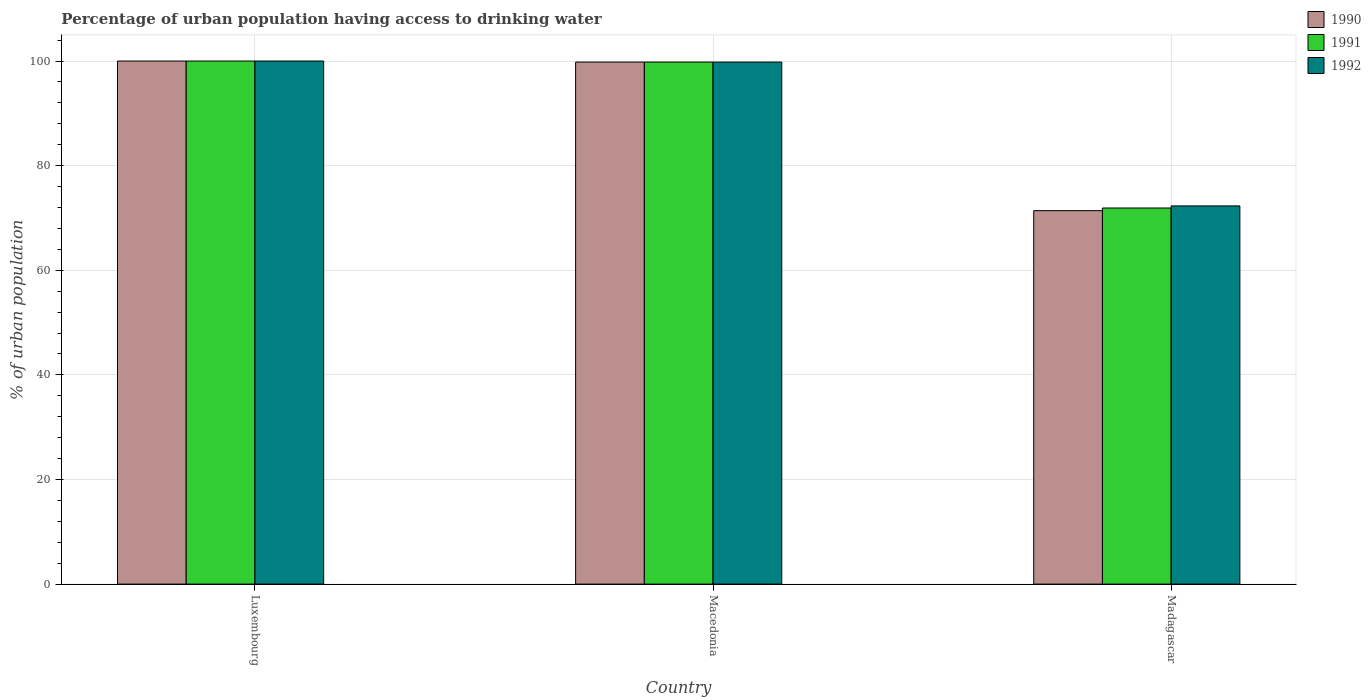How many different coloured bars are there?
Provide a short and direct response. 3. How many groups of bars are there?
Make the answer very short. 3. Are the number of bars per tick equal to the number of legend labels?
Offer a terse response. Yes. How many bars are there on the 1st tick from the left?
Ensure brevity in your answer.  3. What is the label of the 3rd group of bars from the left?
Offer a very short reply. Madagascar. In how many cases, is the number of bars for a given country not equal to the number of legend labels?
Your answer should be compact. 0. What is the percentage of urban population having access to drinking water in 1990 in Macedonia?
Provide a short and direct response. 99.8. Across all countries, what is the minimum percentage of urban population having access to drinking water in 1992?
Your answer should be compact. 72.3. In which country was the percentage of urban population having access to drinking water in 1990 maximum?
Provide a short and direct response. Luxembourg. In which country was the percentage of urban population having access to drinking water in 1991 minimum?
Offer a very short reply. Madagascar. What is the total percentage of urban population having access to drinking water in 1991 in the graph?
Your answer should be compact. 271.7. What is the difference between the percentage of urban population having access to drinking water in 1991 in Luxembourg and that in Macedonia?
Offer a very short reply. 0.2. What is the difference between the percentage of urban population having access to drinking water in 1991 in Madagascar and the percentage of urban population having access to drinking water in 1990 in Macedonia?
Offer a terse response. -27.9. What is the average percentage of urban population having access to drinking water in 1990 per country?
Ensure brevity in your answer.  90.4. What is the ratio of the percentage of urban population having access to drinking water in 1992 in Macedonia to that in Madagascar?
Ensure brevity in your answer.  1.38. Is the percentage of urban population having access to drinking water in 1991 in Luxembourg less than that in Macedonia?
Your answer should be very brief. No. Is the difference between the percentage of urban population having access to drinking water in 1992 in Luxembourg and Madagascar greater than the difference between the percentage of urban population having access to drinking water in 1991 in Luxembourg and Madagascar?
Make the answer very short. No. What is the difference between the highest and the second highest percentage of urban population having access to drinking water in 1992?
Provide a short and direct response. -27.5. What is the difference between the highest and the lowest percentage of urban population having access to drinking water in 1992?
Make the answer very short. 27.7. In how many countries, is the percentage of urban population having access to drinking water in 1992 greater than the average percentage of urban population having access to drinking water in 1992 taken over all countries?
Provide a succinct answer. 2. How many bars are there?
Keep it short and to the point. 9. How many countries are there in the graph?
Offer a terse response. 3. Does the graph contain grids?
Keep it short and to the point. Yes. Where does the legend appear in the graph?
Give a very brief answer. Top right. How many legend labels are there?
Keep it short and to the point. 3. What is the title of the graph?
Give a very brief answer. Percentage of urban population having access to drinking water. What is the label or title of the Y-axis?
Give a very brief answer. % of urban population. What is the % of urban population in 1991 in Luxembourg?
Provide a succinct answer. 100. What is the % of urban population in 1990 in Macedonia?
Give a very brief answer. 99.8. What is the % of urban population in 1991 in Macedonia?
Provide a short and direct response. 99.8. What is the % of urban population of 1992 in Macedonia?
Offer a very short reply. 99.8. What is the % of urban population of 1990 in Madagascar?
Offer a terse response. 71.4. What is the % of urban population of 1991 in Madagascar?
Your answer should be compact. 71.9. What is the % of urban population in 1992 in Madagascar?
Keep it short and to the point. 72.3. Across all countries, what is the maximum % of urban population of 1990?
Offer a very short reply. 100. Across all countries, what is the maximum % of urban population in 1992?
Give a very brief answer. 100. Across all countries, what is the minimum % of urban population in 1990?
Keep it short and to the point. 71.4. Across all countries, what is the minimum % of urban population of 1991?
Your response must be concise. 71.9. Across all countries, what is the minimum % of urban population of 1992?
Make the answer very short. 72.3. What is the total % of urban population in 1990 in the graph?
Give a very brief answer. 271.2. What is the total % of urban population in 1991 in the graph?
Give a very brief answer. 271.7. What is the total % of urban population in 1992 in the graph?
Give a very brief answer. 272.1. What is the difference between the % of urban population in 1990 in Luxembourg and that in Macedonia?
Your answer should be compact. 0.2. What is the difference between the % of urban population in 1991 in Luxembourg and that in Macedonia?
Give a very brief answer. 0.2. What is the difference between the % of urban population in 1990 in Luxembourg and that in Madagascar?
Your answer should be compact. 28.6. What is the difference between the % of urban population of 1991 in Luxembourg and that in Madagascar?
Make the answer very short. 28.1. What is the difference between the % of urban population of 1992 in Luxembourg and that in Madagascar?
Provide a succinct answer. 27.7. What is the difference between the % of urban population in 1990 in Macedonia and that in Madagascar?
Provide a succinct answer. 28.4. What is the difference between the % of urban population in 1991 in Macedonia and that in Madagascar?
Provide a succinct answer. 27.9. What is the difference between the % of urban population in 1992 in Macedonia and that in Madagascar?
Ensure brevity in your answer.  27.5. What is the difference between the % of urban population in 1991 in Luxembourg and the % of urban population in 1992 in Macedonia?
Keep it short and to the point. 0.2. What is the difference between the % of urban population of 1990 in Luxembourg and the % of urban population of 1991 in Madagascar?
Provide a succinct answer. 28.1. What is the difference between the % of urban population of 1990 in Luxembourg and the % of urban population of 1992 in Madagascar?
Provide a succinct answer. 27.7. What is the difference between the % of urban population in 1991 in Luxembourg and the % of urban population in 1992 in Madagascar?
Offer a terse response. 27.7. What is the difference between the % of urban population in 1990 in Macedonia and the % of urban population in 1991 in Madagascar?
Make the answer very short. 27.9. What is the difference between the % of urban population in 1990 in Macedonia and the % of urban population in 1992 in Madagascar?
Make the answer very short. 27.5. What is the average % of urban population in 1990 per country?
Your answer should be very brief. 90.4. What is the average % of urban population of 1991 per country?
Your answer should be very brief. 90.57. What is the average % of urban population in 1992 per country?
Offer a very short reply. 90.7. What is the difference between the % of urban population in 1991 and % of urban population in 1992 in Luxembourg?
Keep it short and to the point. 0. What is the difference between the % of urban population in 1990 and % of urban population in 1992 in Macedonia?
Provide a succinct answer. 0. What is the difference between the % of urban population in 1990 and % of urban population in 1992 in Madagascar?
Offer a very short reply. -0.9. What is the ratio of the % of urban population of 1990 in Luxembourg to that in Macedonia?
Offer a very short reply. 1. What is the ratio of the % of urban population in 1991 in Luxembourg to that in Macedonia?
Make the answer very short. 1. What is the ratio of the % of urban population of 1990 in Luxembourg to that in Madagascar?
Offer a very short reply. 1.4. What is the ratio of the % of urban population of 1991 in Luxembourg to that in Madagascar?
Make the answer very short. 1.39. What is the ratio of the % of urban population of 1992 in Luxembourg to that in Madagascar?
Your response must be concise. 1.38. What is the ratio of the % of urban population of 1990 in Macedonia to that in Madagascar?
Make the answer very short. 1.4. What is the ratio of the % of urban population of 1991 in Macedonia to that in Madagascar?
Your response must be concise. 1.39. What is the ratio of the % of urban population of 1992 in Macedonia to that in Madagascar?
Offer a very short reply. 1.38. What is the difference between the highest and the lowest % of urban population in 1990?
Give a very brief answer. 28.6. What is the difference between the highest and the lowest % of urban population in 1991?
Offer a terse response. 28.1. What is the difference between the highest and the lowest % of urban population in 1992?
Your answer should be compact. 27.7. 